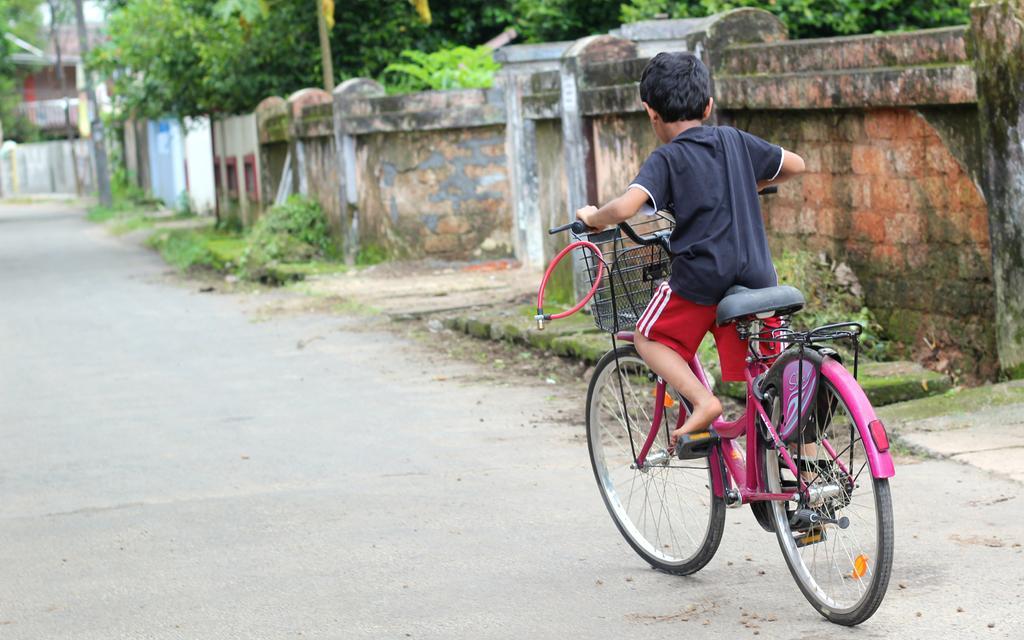In one or two sentences, can you explain what this image depicts? a person is riding a pink color bicycle on the road. at the right side there is a brick wall and behind that there are trees. 